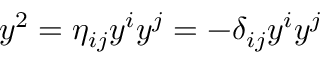Convert formula to latex. <formula><loc_0><loc_0><loc_500><loc_500>y ^ { 2 } = \eta _ { i j } y ^ { i } y ^ { j } = - \delta _ { i j } y ^ { i } y ^ { j }</formula> 